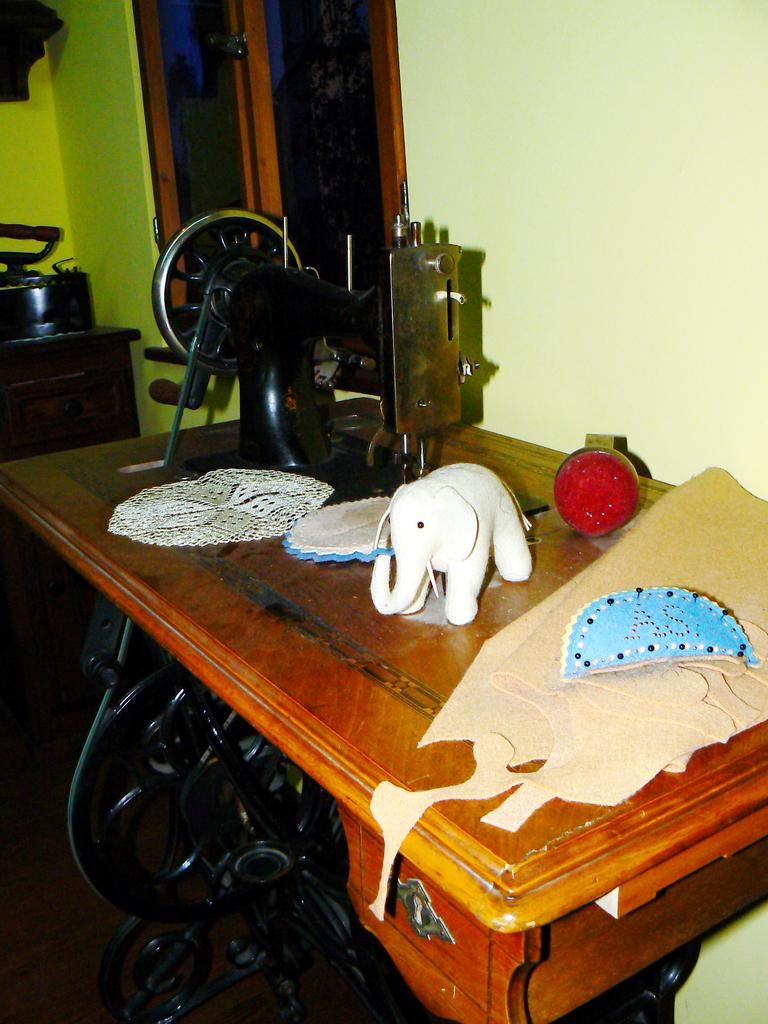What is the main object in the image? There is a sewing machine in the image. What type of toy can be seen in the image? There is an elephant toy in the image. What else is present in the image besides the sewing machine and the toy? There are papers in the image. What can be seen in the background of the image? There is a wall and a window in the background of the image. How many houses can be seen in the image? There is no house present in the image; it features a sewing machine, an elephant toy, papers, a wall, and a window. 